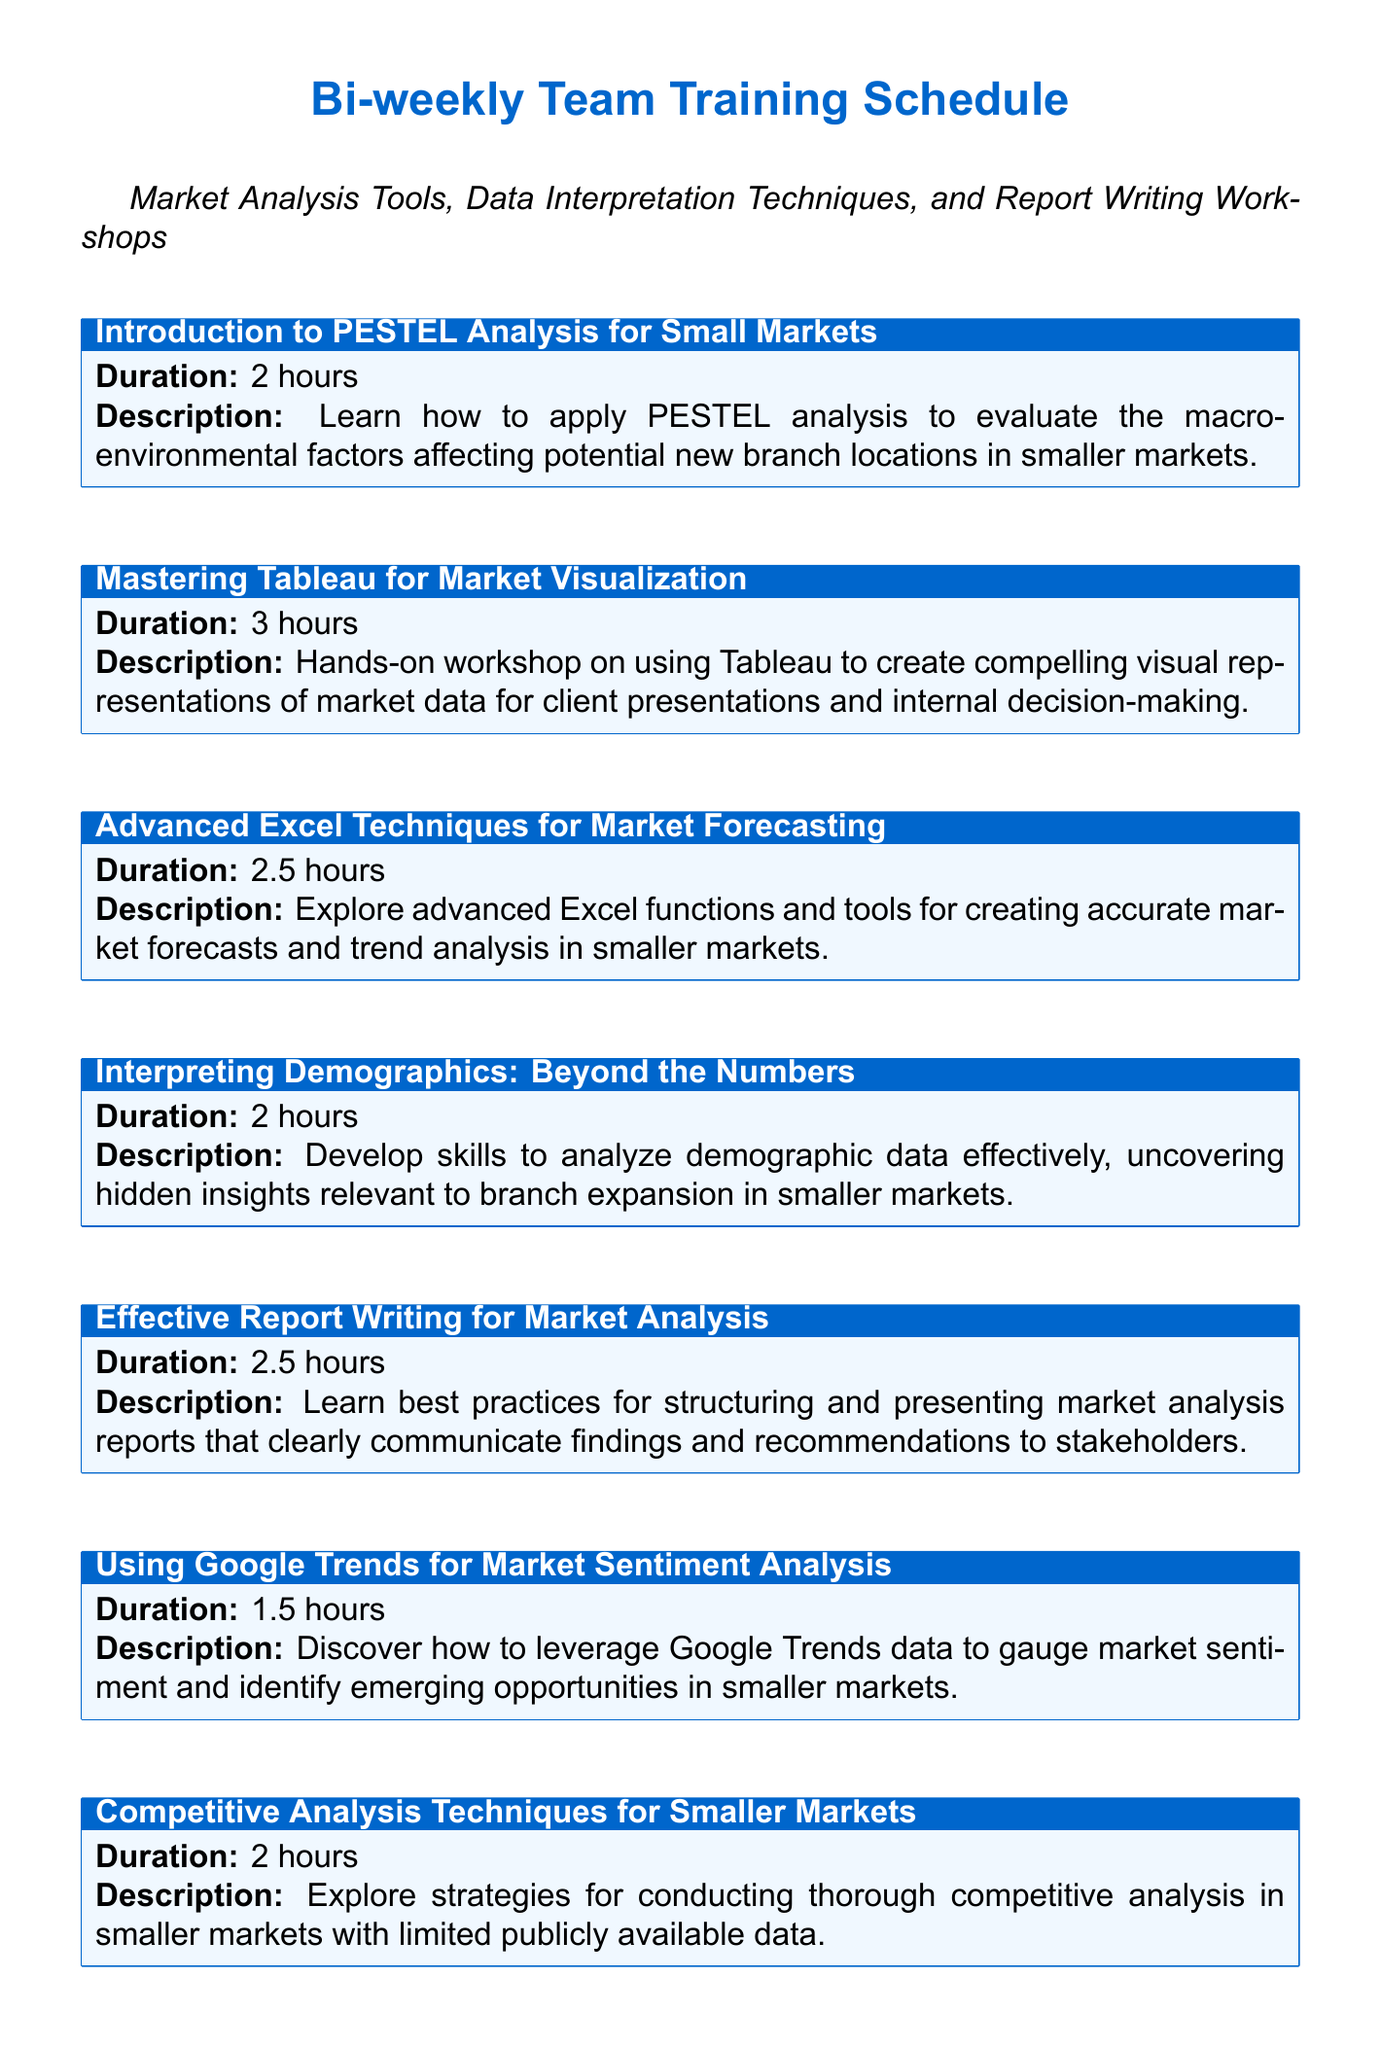What is the duration of the workshop on Tableau? The duration of the "Mastering Tableau for Market Visualization" workshop is stated as 3 hours.
Answer: 3 hours How many hours is the training on Financial Modeling? The "Financial Modeling for Branch Feasibility Studies" training is specified as having a duration of 3 hours.
Answer: 3 hours What is the main focus of the "Using Google Trends for Market Sentiment Analysis" session? The focus of the "Using Google Trends for Market Sentiment Analysis" session is on leveraging Google Trends to gauge market sentiment.
Answer: Market sentiment Which module emphasizes effective report writing? The module titled "Effective Report Writing for Market Analysis" emphasizes best practices for report writing.
Answer: Effective Report Writing for Market Analysis How long is the longest training module? The longest training module, which is "Mastering Tableau for Market Visualization" and "Financial Modeling for Branch Feasibility Studies," both last 3 hours.
Answer: 3 hours Which training session specifically addresses GIS mapping? The training session that specifically addresses GIS mapping is "GIS Mapping for Branch Location Analysis."
Answer: GIS Mapping for Branch Location Analysis Does the schedule include any workshops focusing on presentation skills? Yes, the schedule includes the "Effective Presentation Skills for Market Analysis Findings" workshop focusing on presentation skills.
Answer: Yes What type of analysis does the "Introduction to PESTEL Analysis for Small Markets" cover? The "Introduction to PESTEL Analysis for Small Markets" covers macro-environmental factors affecting potential new branch locations.
Answer: Macro-environmental factors 